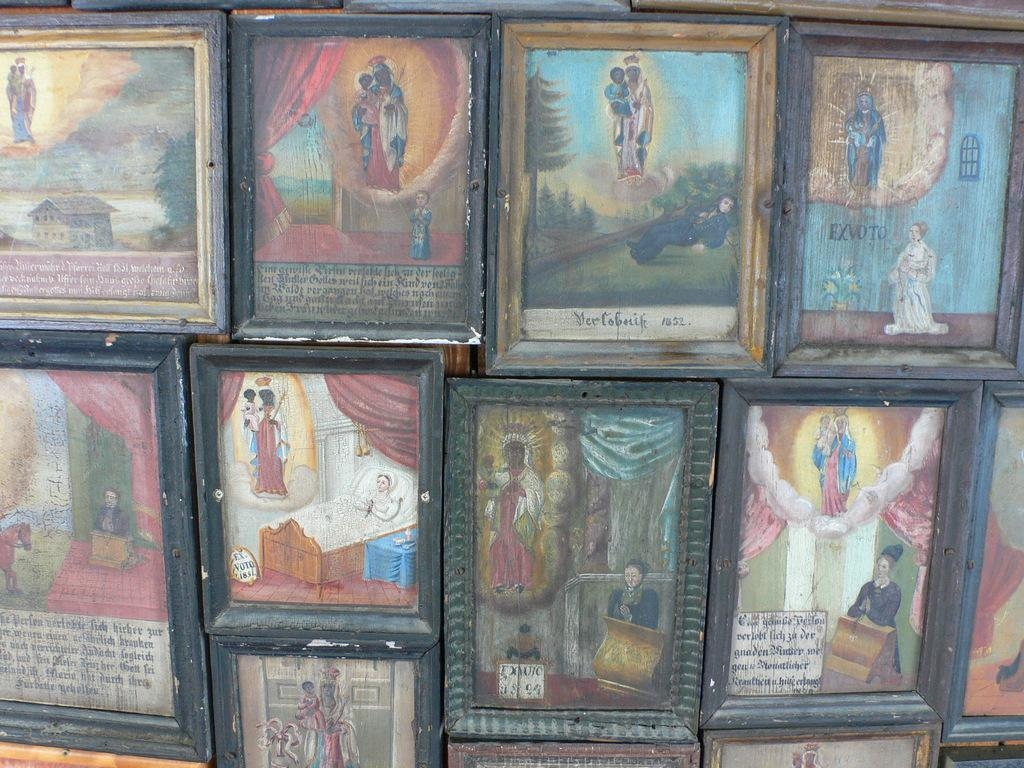<image>
Summarize the visual content of the image. Religious pictures from the medieval era, the word Exvoto is visible. 